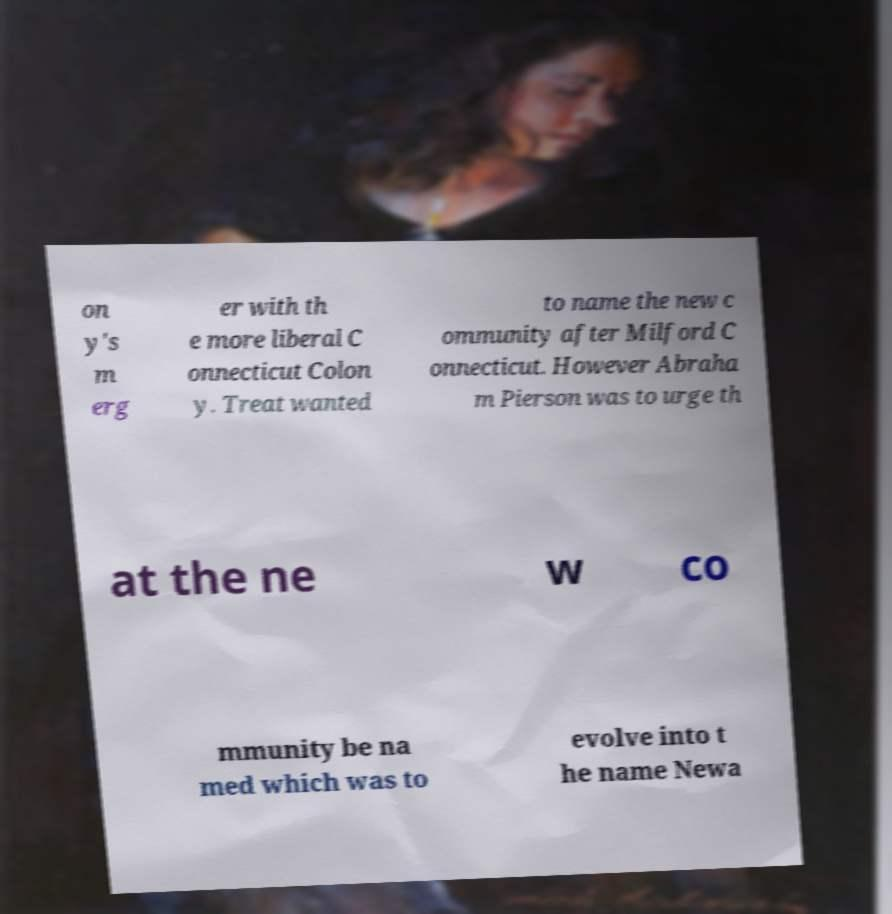What messages or text are displayed in this image? I need them in a readable, typed format. on y's m erg er with th e more liberal C onnecticut Colon y. Treat wanted to name the new c ommunity after Milford C onnecticut. However Abraha m Pierson was to urge th at the ne w co mmunity be na med which was to evolve into t he name Newa 